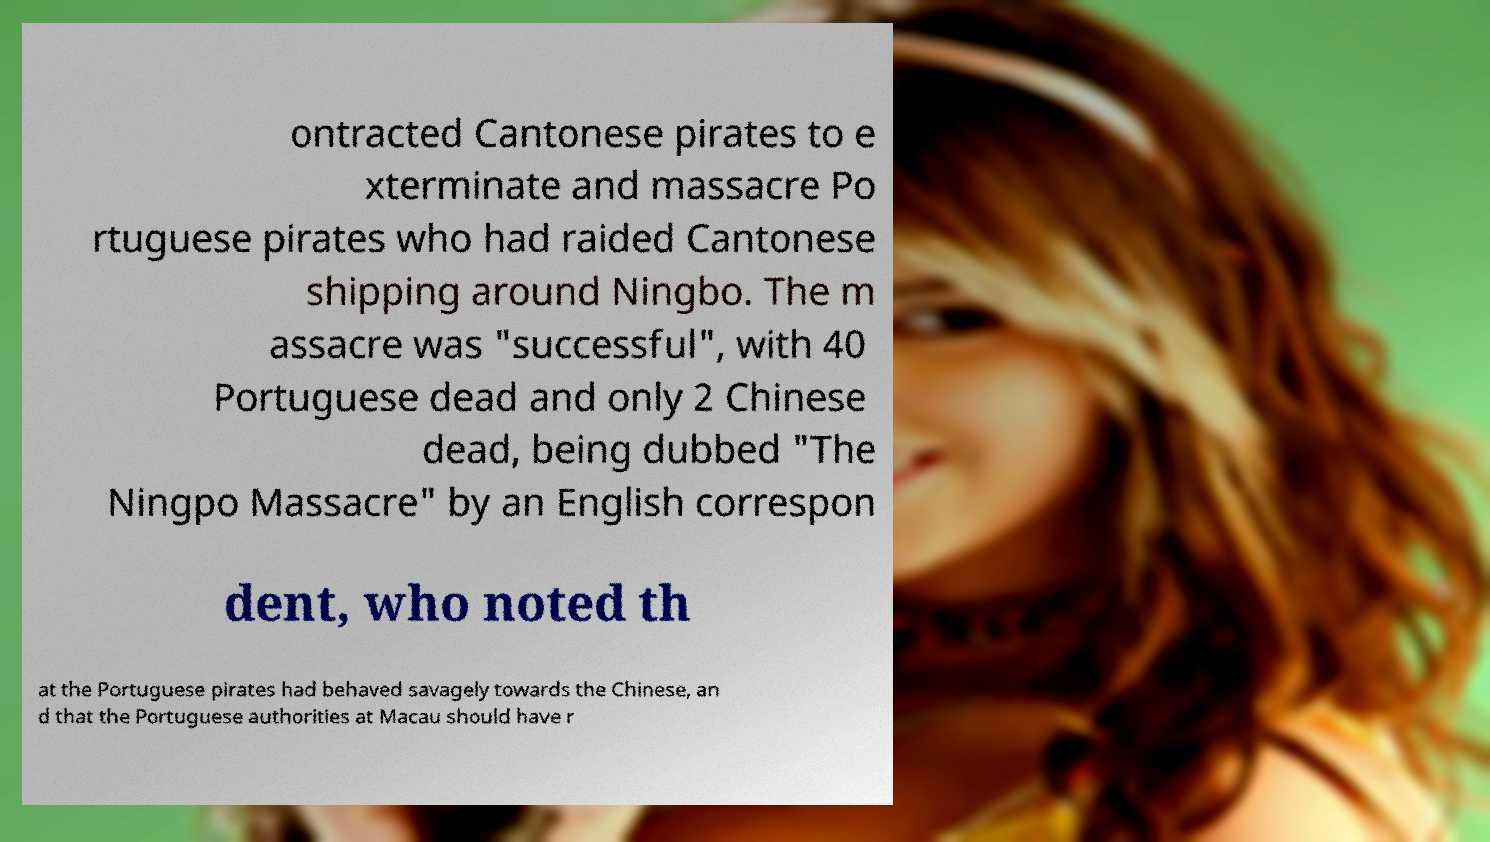I need the written content from this picture converted into text. Can you do that? ontracted Cantonese pirates to e xterminate and massacre Po rtuguese pirates who had raided Cantonese shipping around Ningbo. The m assacre was "successful", with 40 Portuguese dead and only 2 Chinese dead, being dubbed "The Ningpo Massacre" by an English correspon dent, who noted th at the Portuguese pirates had behaved savagely towards the Chinese, an d that the Portuguese authorities at Macau should have r 